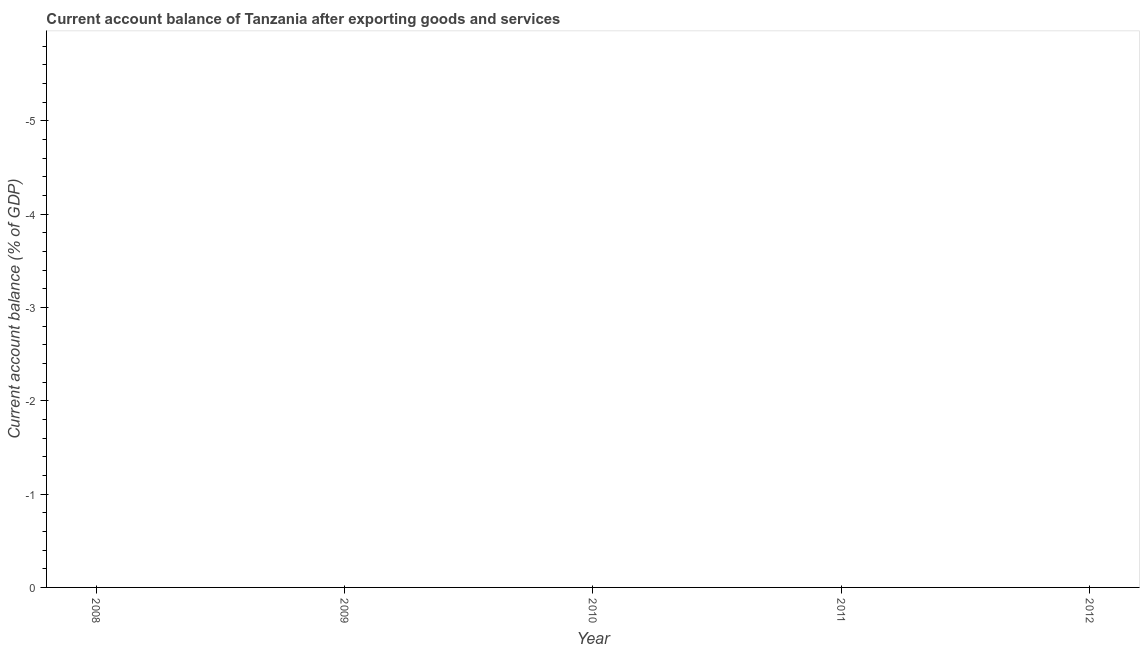What is the current account balance in 2012?
Give a very brief answer. 0. What is the average current account balance per year?
Your answer should be compact. 0. In how many years, is the current account balance greater than the average current account balance taken over all years?
Provide a succinct answer. 0. Does the current account balance monotonically increase over the years?
Keep it short and to the point. No. How many dotlines are there?
Your response must be concise. 0. Does the graph contain grids?
Ensure brevity in your answer.  No. What is the title of the graph?
Ensure brevity in your answer.  Current account balance of Tanzania after exporting goods and services. What is the label or title of the X-axis?
Your response must be concise. Year. What is the label or title of the Y-axis?
Your answer should be very brief. Current account balance (% of GDP). What is the Current account balance (% of GDP) in 2008?
Make the answer very short. 0. What is the Current account balance (% of GDP) in 2010?
Your answer should be compact. 0. What is the Current account balance (% of GDP) in 2011?
Offer a terse response. 0. What is the Current account balance (% of GDP) in 2012?
Offer a terse response. 0. 